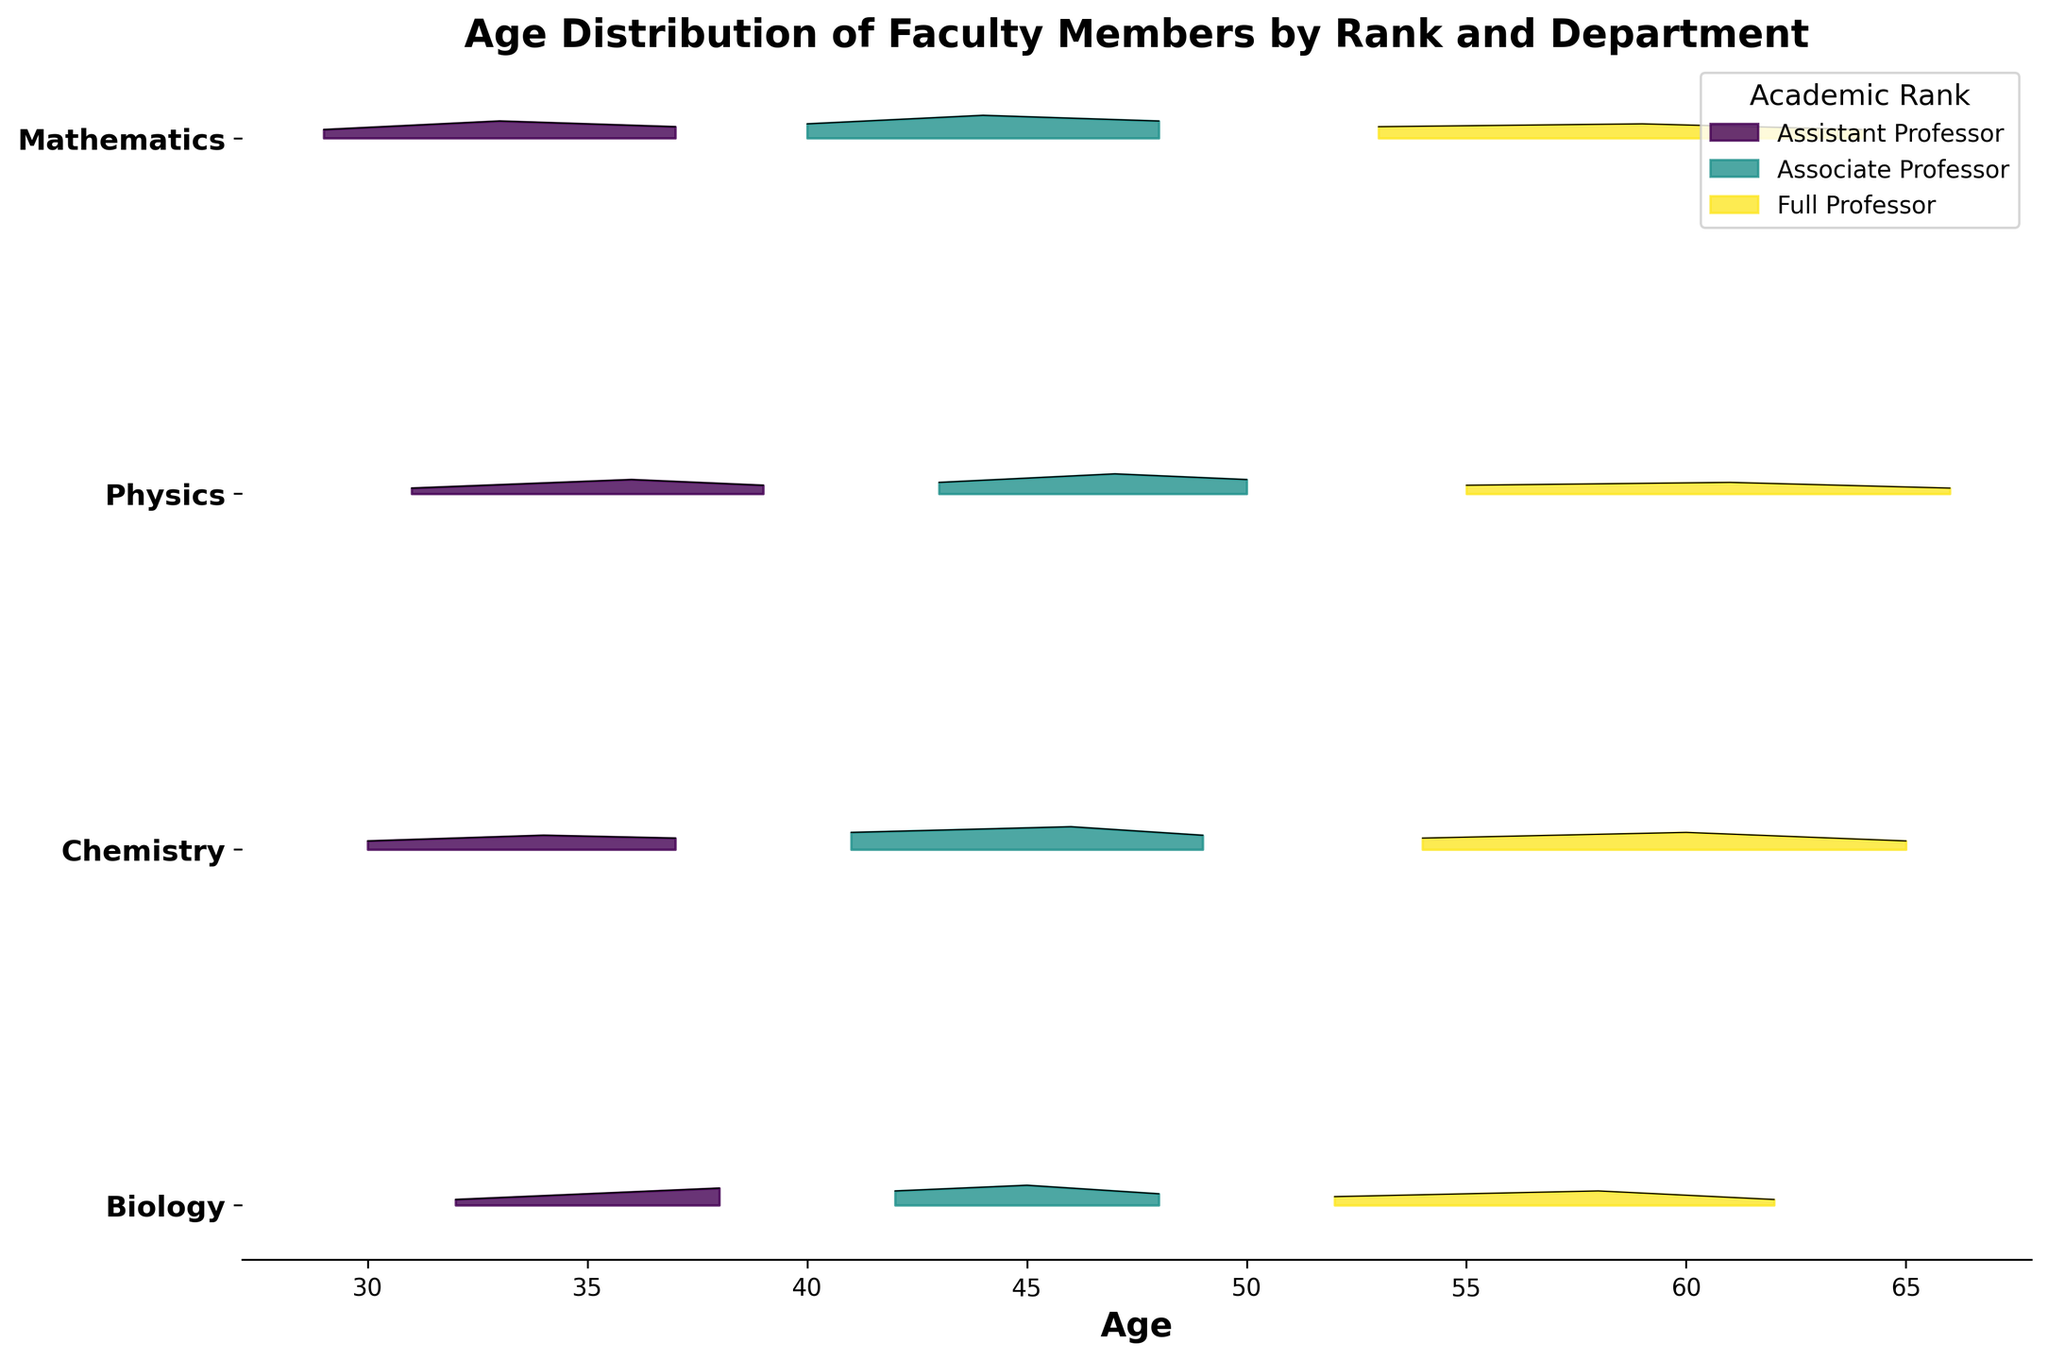What's the title of the figure? The title of the figure is displayed at the top and reads "Age Distribution of Faculty Members by Rank and Department".
Answer: Age Distribution of Faculty Members by Rank and Department Which department has the oldest Full Professor age distribution? Look at the topmost ridgeline plot for each department. The Full Professor age distribution peaks are at higher values for the Physics department compared to other departments.
Answer: Physics How does the age distribution of Assistant Professors in Biology compare to that in Chemistry? Compare the ridgeline plots for Assistant Professors in Biology and Chemistry. The peak age for Assistant Professors in Chemistry is at a younger age than in Biology.
Answer: Chemistry peaks at a younger age Is there any department where the Associate Professors' age distribution peaks higher than both Assistant and Full Professors’ age distributions? Compare the height of the peaks for Associate Professors against those for Assistant and Full Professors in each department. The Associate Professors in Chemistry have a higher peak than both their Assistant and Full Professor counterparts.
Answer: Chemistry Which department has the most noticeable spread in age distribution for each rank? To determine the spread, observe the extent of the x-axis covered by the ridgeline plots for each rank in each department. The Mathematics department shows a considerable spread in age distribution across all ranks.
Answer: Mathematics Are there any departments where Assistant Professors' age distribution covers a wider range than the Full Professors’? Compare the width of the ridgeline plots for Assistant Professors and Full Professors in each department. In the Biology department, the age distribution of Assistant Professors covers a wider range than that of Full Professors.
Answer: Biology Which rank in the Physics department has the least density in its age distribution? Look at the height of the ridgeline plots for each rank in the Physics department. The Assistant Professors have the least density compared to Associate and Full Professors.
Answer: Assistant Professors How does the age distribution of Full Professors in Mathematics differ from that in Chemistry? Compare the ridgeline plots for Full Professors in Mathematics and Chemistry. The peak age distribution for Full Professors in Mathematics occurs at a younger age than in Chemistry.
Answer: Mathematics peaks at a younger age What is the approximate age at the peak density for Associate Professors in the Chemistry department? Find the highest peak in the ridgeline plot for Associate Professors in the Chemistry department. The peak occurs at around age 46.
Answer: 46 Which department has a more uniform age distribution across all academic ranks? Observe which department has ridgeline plots that appear evenly distributed with less pronounced peaks. The Mathematics department’s distributions for each rank are more uniform compared to others.
Answer: Mathematics 